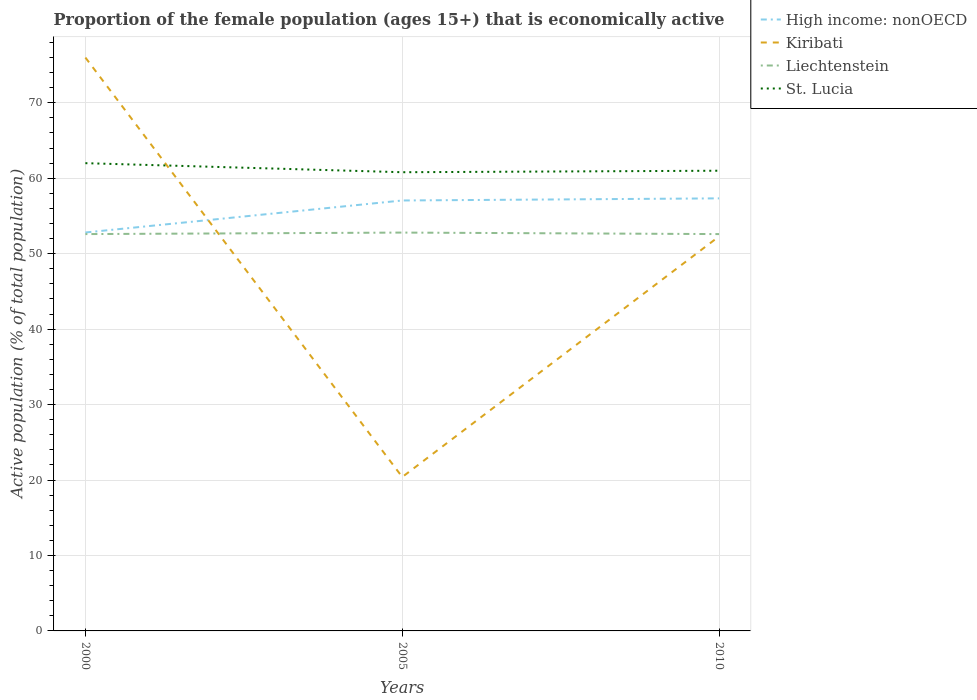Across all years, what is the maximum proportion of the female population that is economically active in High income: nonOECD?
Keep it short and to the point. 52.81. What is the difference between the highest and the second highest proportion of the female population that is economically active in Kiribati?
Make the answer very short. 55.6. How many lines are there?
Provide a succinct answer. 4. How many years are there in the graph?
Offer a terse response. 3. What is the difference between two consecutive major ticks on the Y-axis?
Provide a succinct answer. 10. Does the graph contain any zero values?
Your answer should be very brief. No. Where does the legend appear in the graph?
Provide a short and direct response. Top right. What is the title of the graph?
Ensure brevity in your answer.  Proportion of the female population (ages 15+) that is economically active. What is the label or title of the X-axis?
Give a very brief answer. Years. What is the label or title of the Y-axis?
Offer a terse response. Active population (% of total population). What is the Active population (% of total population) in High income: nonOECD in 2000?
Provide a succinct answer. 52.81. What is the Active population (% of total population) in Liechtenstein in 2000?
Your answer should be compact. 52.6. What is the Active population (% of total population) of St. Lucia in 2000?
Your answer should be compact. 62. What is the Active population (% of total population) in High income: nonOECD in 2005?
Provide a short and direct response. 57.05. What is the Active population (% of total population) in Kiribati in 2005?
Ensure brevity in your answer.  20.4. What is the Active population (% of total population) of Liechtenstein in 2005?
Your answer should be very brief. 52.8. What is the Active population (% of total population) in St. Lucia in 2005?
Make the answer very short. 60.8. What is the Active population (% of total population) of High income: nonOECD in 2010?
Your answer should be very brief. 57.34. What is the Active population (% of total population) of Kiribati in 2010?
Make the answer very short. 52.3. What is the Active population (% of total population) in Liechtenstein in 2010?
Provide a short and direct response. 52.6. What is the Active population (% of total population) of St. Lucia in 2010?
Provide a short and direct response. 61. Across all years, what is the maximum Active population (% of total population) of High income: nonOECD?
Give a very brief answer. 57.34. Across all years, what is the maximum Active population (% of total population) in Kiribati?
Provide a succinct answer. 76. Across all years, what is the maximum Active population (% of total population) of Liechtenstein?
Offer a very short reply. 52.8. Across all years, what is the maximum Active population (% of total population) in St. Lucia?
Your answer should be compact. 62. Across all years, what is the minimum Active population (% of total population) in High income: nonOECD?
Keep it short and to the point. 52.81. Across all years, what is the minimum Active population (% of total population) of Kiribati?
Offer a terse response. 20.4. Across all years, what is the minimum Active population (% of total population) of Liechtenstein?
Provide a short and direct response. 52.6. Across all years, what is the minimum Active population (% of total population) of St. Lucia?
Ensure brevity in your answer.  60.8. What is the total Active population (% of total population) in High income: nonOECD in the graph?
Your answer should be very brief. 167.2. What is the total Active population (% of total population) of Kiribati in the graph?
Give a very brief answer. 148.7. What is the total Active population (% of total population) in Liechtenstein in the graph?
Your answer should be very brief. 158. What is the total Active population (% of total population) of St. Lucia in the graph?
Keep it short and to the point. 183.8. What is the difference between the Active population (% of total population) in High income: nonOECD in 2000 and that in 2005?
Offer a terse response. -4.24. What is the difference between the Active population (% of total population) in Kiribati in 2000 and that in 2005?
Give a very brief answer. 55.6. What is the difference between the Active population (% of total population) of Liechtenstein in 2000 and that in 2005?
Provide a succinct answer. -0.2. What is the difference between the Active population (% of total population) of High income: nonOECD in 2000 and that in 2010?
Offer a very short reply. -4.52. What is the difference between the Active population (% of total population) of Kiribati in 2000 and that in 2010?
Provide a short and direct response. 23.7. What is the difference between the Active population (% of total population) of Liechtenstein in 2000 and that in 2010?
Your answer should be compact. 0. What is the difference between the Active population (% of total population) in St. Lucia in 2000 and that in 2010?
Provide a short and direct response. 1. What is the difference between the Active population (% of total population) in High income: nonOECD in 2005 and that in 2010?
Keep it short and to the point. -0.28. What is the difference between the Active population (% of total population) of Kiribati in 2005 and that in 2010?
Your answer should be compact. -31.9. What is the difference between the Active population (% of total population) in High income: nonOECD in 2000 and the Active population (% of total population) in Kiribati in 2005?
Ensure brevity in your answer.  32.41. What is the difference between the Active population (% of total population) of High income: nonOECD in 2000 and the Active population (% of total population) of Liechtenstein in 2005?
Ensure brevity in your answer.  0.01. What is the difference between the Active population (% of total population) of High income: nonOECD in 2000 and the Active population (% of total population) of St. Lucia in 2005?
Offer a very short reply. -7.99. What is the difference between the Active population (% of total population) in Kiribati in 2000 and the Active population (% of total population) in Liechtenstein in 2005?
Your answer should be very brief. 23.2. What is the difference between the Active population (% of total population) in Kiribati in 2000 and the Active population (% of total population) in St. Lucia in 2005?
Offer a terse response. 15.2. What is the difference between the Active population (% of total population) in High income: nonOECD in 2000 and the Active population (% of total population) in Kiribati in 2010?
Give a very brief answer. 0.51. What is the difference between the Active population (% of total population) in High income: nonOECD in 2000 and the Active population (% of total population) in Liechtenstein in 2010?
Keep it short and to the point. 0.21. What is the difference between the Active population (% of total population) of High income: nonOECD in 2000 and the Active population (% of total population) of St. Lucia in 2010?
Your response must be concise. -8.19. What is the difference between the Active population (% of total population) of Kiribati in 2000 and the Active population (% of total population) of Liechtenstein in 2010?
Offer a very short reply. 23.4. What is the difference between the Active population (% of total population) in Kiribati in 2000 and the Active population (% of total population) in St. Lucia in 2010?
Offer a very short reply. 15. What is the difference between the Active population (% of total population) of High income: nonOECD in 2005 and the Active population (% of total population) of Kiribati in 2010?
Offer a terse response. 4.75. What is the difference between the Active population (% of total population) in High income: nonOECD in 2005 and the Active population (% of total population) in Liechtenstein in 2010?
Provide a succinct answer. 4.45. What is the difference between the Active population (% of total population) of High income: nonOECD in 2005 and the Active population (% of total population) of St. Lucia in 2010?
Ensure brevity in your answer.  -3.95. What is the difference between the Active population (% of total population) in Kiribati in 2005 and the Active population (% of total population) in Liechtenstein in 2010?
Your response must be concise. -32.2. What is the difference between the Active population (% of total population) of Kiribati in 2005 and the Active population (% of total population) of St. Lucia in 2010?
Keep it short and to the point. -40.6. What is the difference between the Active population (% of total population) of Liechtenstein in 2005 and the Active population (% of total population) of St. Lucia in 2010?
Ensure brevity in your answer.  -8.2. What is the average Active population (% of total population) in High income: nonOECD per year?
Provide a short and direct response. 55.73. What is the average Active population (% of total population) in Kiribati per year?
Offer a terse response. 49.57. What is the average Active population (% of total population) in Liechtenstein per year?
Offer a very short reply. 52.67. What is the average Active population (% of total population) of St. Lucia per year?
Provide a succinct answer. 61.27. In the year 2000, what is the difference between the Active population (% of total population) of High income: nonOECD and Active population (% of total population) of Kiribati?
Provide a short and direct response. -23.19. In the year 2000, what is the difference between the Active population (% of total population) of High income: nonOECD and Active population (% of total population) of Liechtenstein?
Your answer should be compact. 0.21. In the year 2000, what is the difference between the Active population (% of total population) in High income: nonOECD and Active population (% of total population) in St. Lucia?
Keep it short and to the point. -9.19. In the year 2000, what is the difference between the Active population (% of total population) of Kiribati and Active population (% of total population) of Liechtenstein?
Your answer should be compact. 23.4. In the year 2000, what is the difference between the Active population (% of total population) in Liechtenstein and Active population (% of total population) in St. Lucia?
Ensure brevity in your answer.  -9.4. In the year 2005, what is the difference between the Active population (% of total population) in High income: nonOECD and Active population (% of total population) in Kiribati?
Offer a terse response. 36.65. In the year 2005, what is the difference between the Active population (% of total population) in High income: nonOECD and Active population (% of total population) in Liechtenstein?
Keep it short and to the point. 4.25. In the year 2005, what is the difference between the Active population (% of total population) of High income: nonOECD and Active population (% of total population) of St. Lucia?
Make the answer very short. -3.75. In the year 2005, what is the difference between the Active population (% of total population) in Kiribati and Active population (% of total population) in Liechtenstein?
Ensure brevity in your answer.  -32.4. In the year 2005, what is the difference between the Active population (% of total population) of Kiribati and Active population (% of total population) of St. Lucia?
Give a very brief answer. -40.4. In the year 2010, what is the difference between the Active population (% of total population) of High income: nonOECD and Active population (% of total population) of Kiribati?
Provide a succinct answer. 5.04. In the year 2010, what is the difference between the Active population (% of total population) of High income: nonOECD and Active population (% of total population) of Liechtenstein?
Ensure brevity in your answer.  4.74. In the year 2010, what is the difference between the Active population (% of total population) of High income: nonOECD and Active population (% of total population) of St. Lucia?
Give a very brief answer. -3.66. In the year 2010, what is the difference between the Active population (% of total population) of Kiribati and Active population (% of total population) of Liechtenstein?
Make the answer very short. -0.3. What is the ratio of the Active population (% of total population) in High income: nonOECD in 2000 to that in 2005?
Your answer should be very brief. 0.93. What is the ratio of the Active population (% of total population) in Kiribati in 2000 to that in 2005?
Keep it short and to the point. 3.73. What is the ratio of the Active population (% of total population) in St. Lucia in 2000 to that in 2005?
Give a very brief answer. 1.02. What is the ratio of the Active population (% of total population) of High income: nonOECD in 2000 to that in 2010?
Provide a short and direct response. 0.92. What is the ratio of the Active population (% of total population) in Kiribati in 2000 to that in 2010?
Your answer should be compact. 1.45. What is the ratio of the Active population (% of total population) of St. Lucia in 2000 to that in 2010?
Offer a terse response. 1.02. What is the ratio of the Active population (% of total population) in High income: nonOECD in 2005 to that in 2010?
Keep it short and to the point. 1. What is the ratio of the Active population (% of total population) of Kiribati in 2005 to that in 2010?
Provide a succinct answer. 0.39. What is the difference between the highest and the second highest Active population (% of total population) in High income: nonOECD?
Offer a terse response. 0.28. What is the difference between the highest and the second highest Active population (% of total population) of Kiribati?
Your response must be concise. 23.7. What is the difference between the highest and the second highest Active population (% of total population) in Liechtenstein?
Your answer should be very brief. 0.2. What is the difference between the highest and the second highest Active population (% of total population) of St. Lucia?
Your answer should be very brief. 1. What is the difference between the highest and the lowest Active population (% of total population) of High income: nonOECD?
Keep it short and to the point. 4.52. What is the difference between the highest and the lowest Active population (% of total population) in Kiribati?
Make the answer very short. 55.6. What is the difference between the highest and the lowest Active population (% of total population) of St. Lucia?
Your answer should be compact. 1.2. 